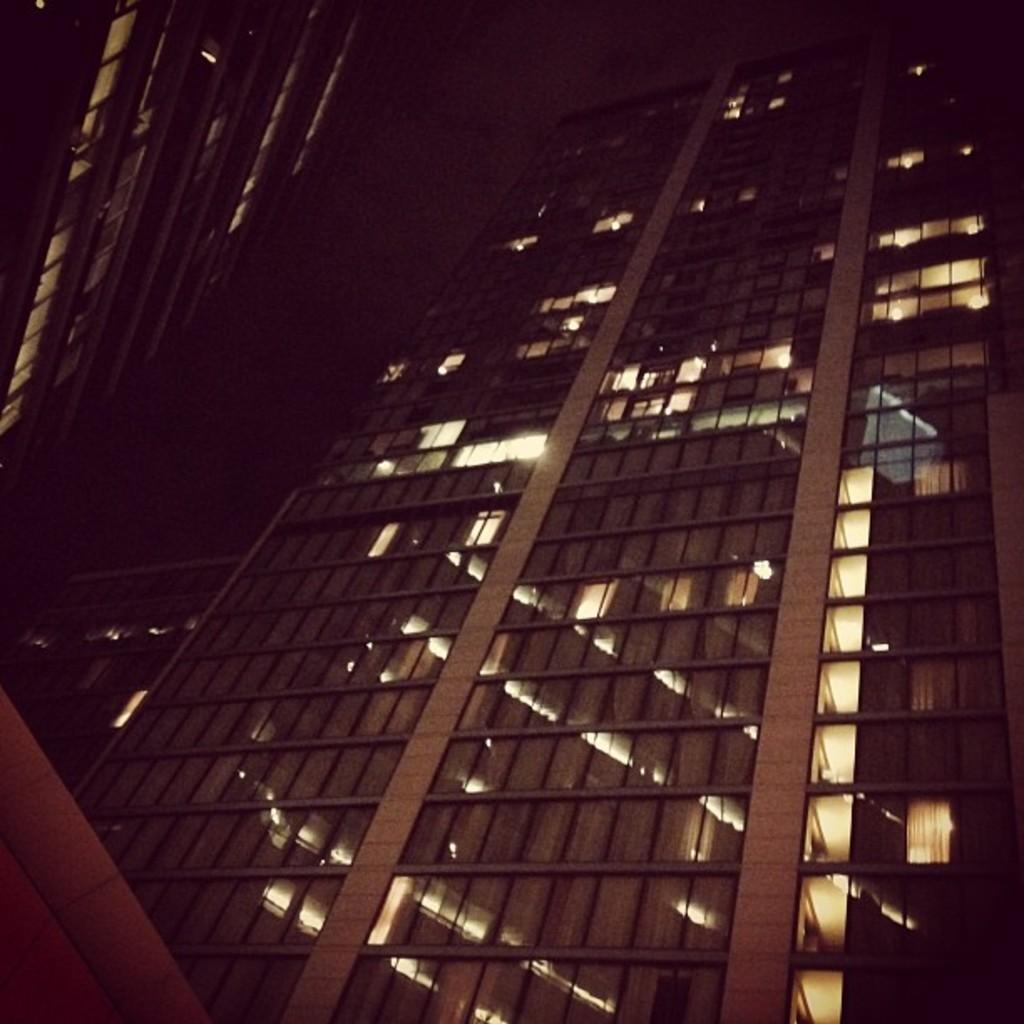What type of structures can be seen in the image? There are buildings in the image. What is the color of the background in the image? The background of the image is dark. How does the bedroom look in the image? There is no bedroom present in the image; it features buildings and a dark background. Can you tell me how many visitors are in the image? There is no reference to any visitors in the image, as it only contains buildings and a dark background. 